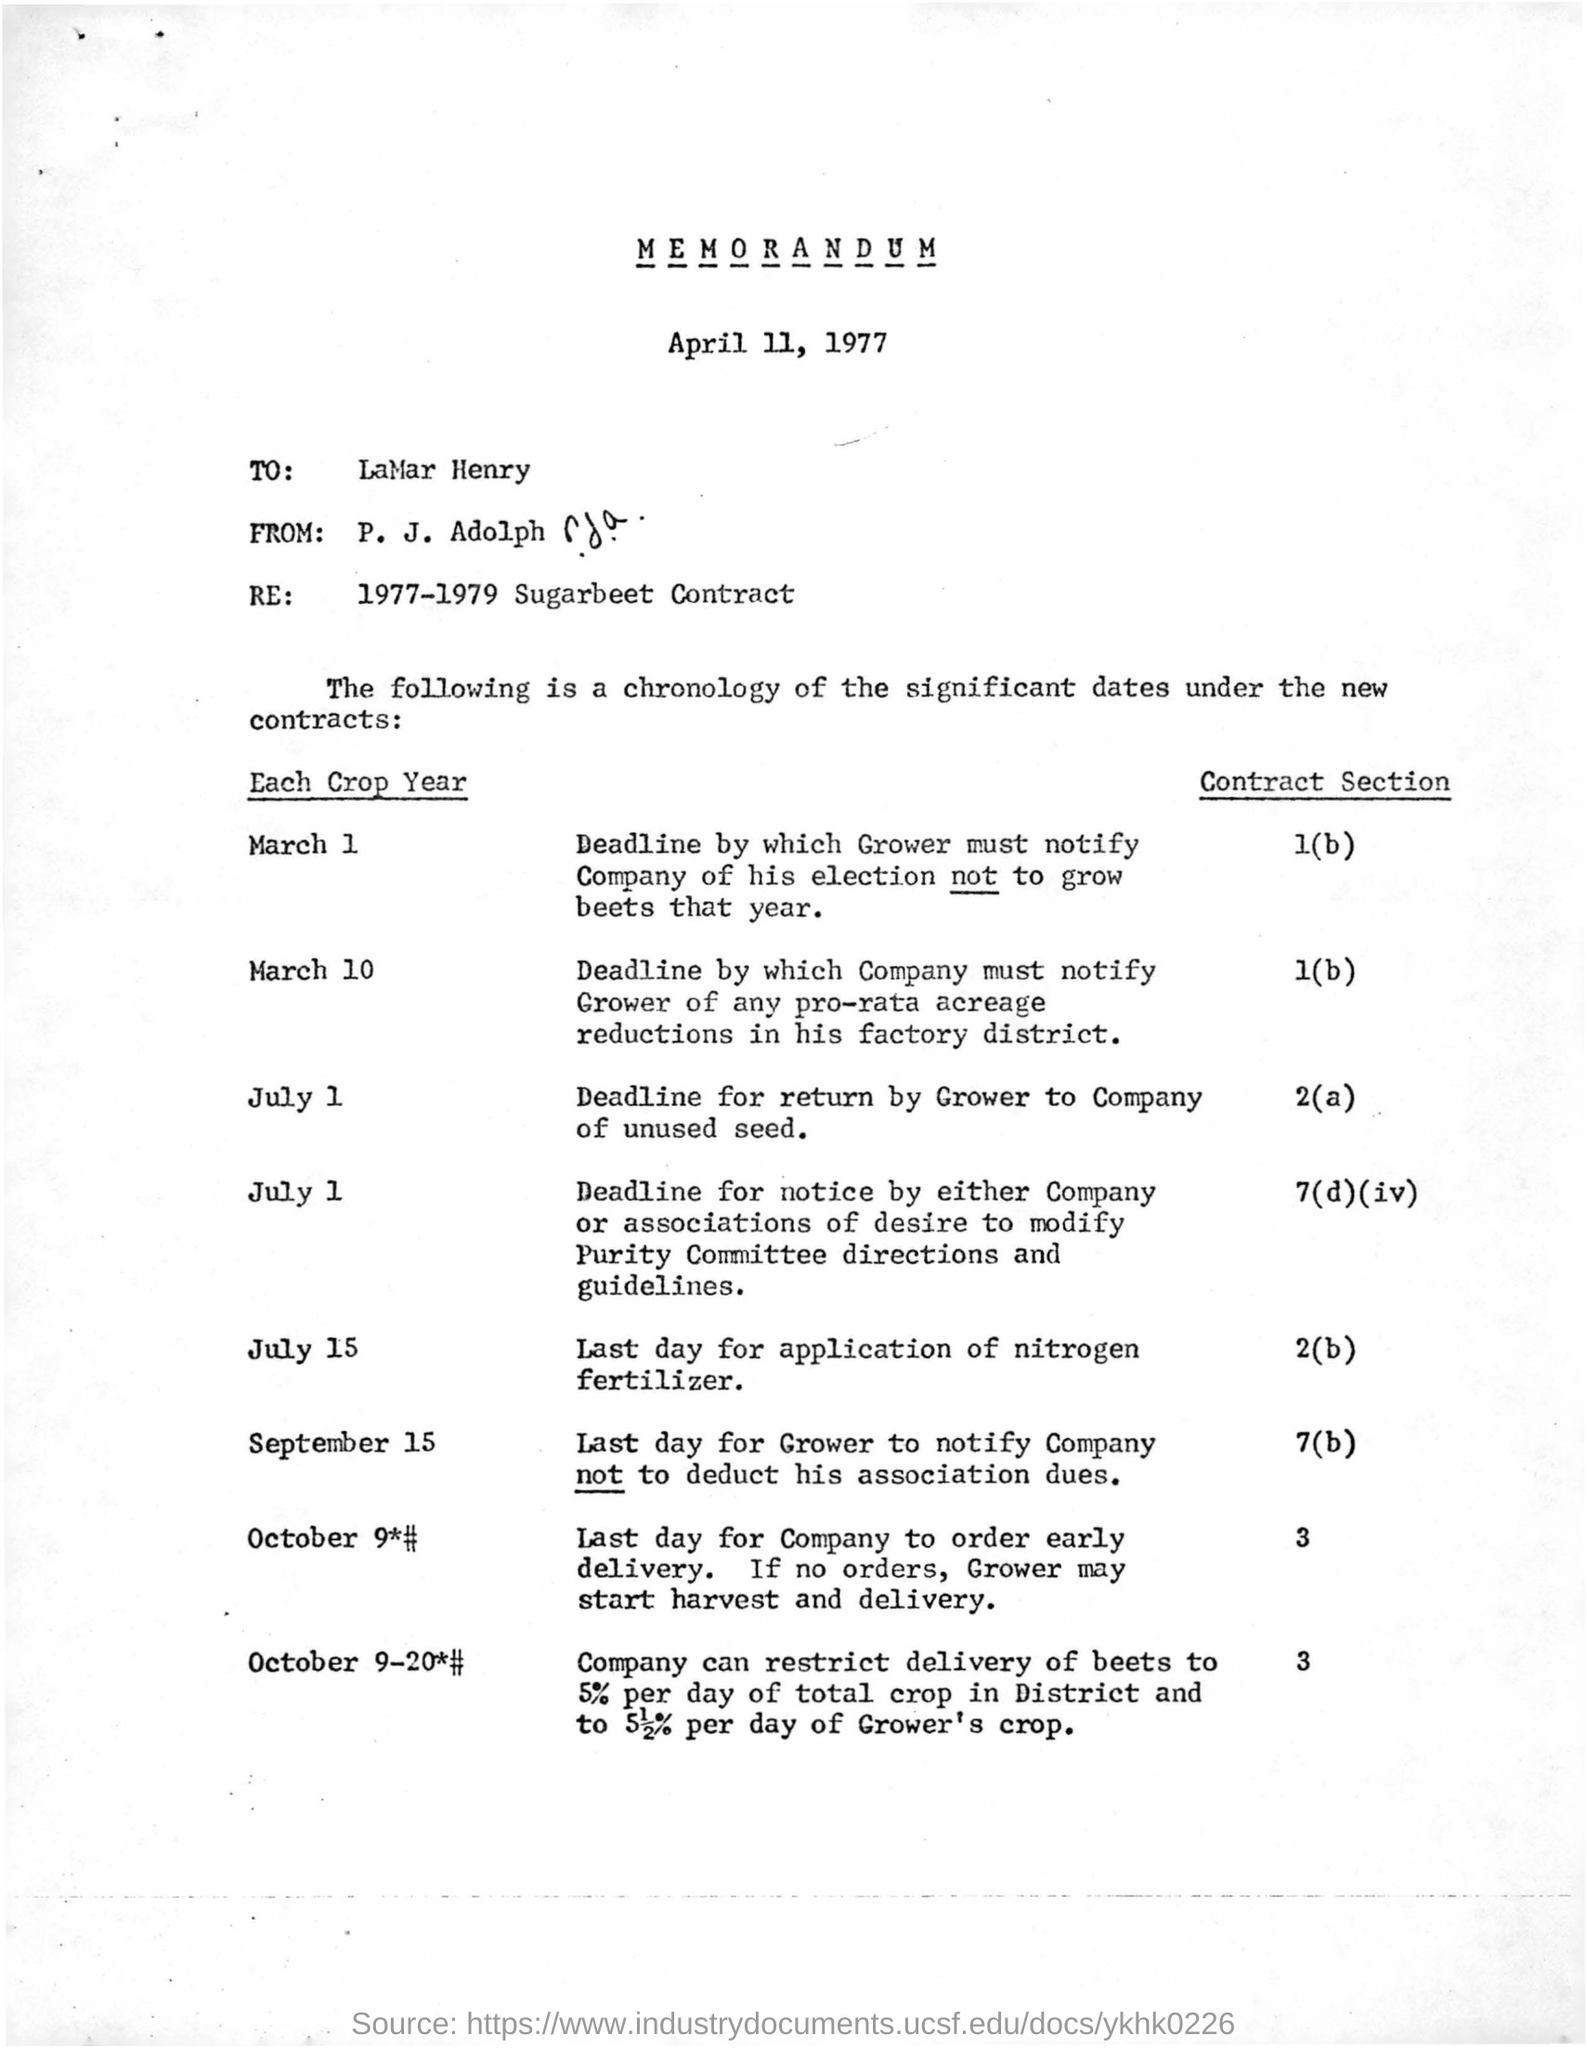Indicate a few pertinent items in this graphic. P. J. Adolph wrote this letter to Lamar Henry. The date mentioned in the letter is April 11, 1977. 